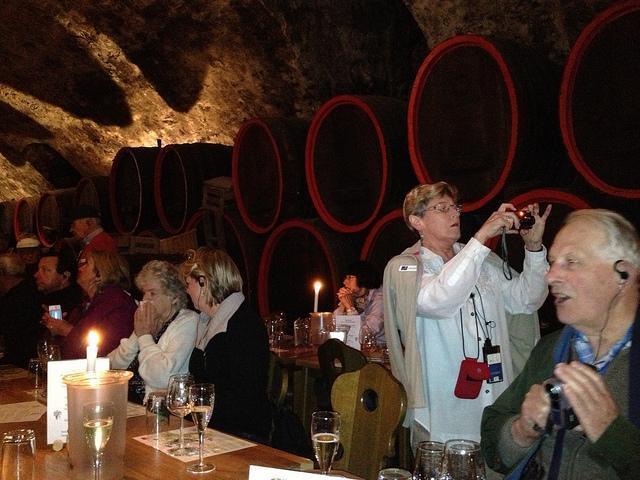How many people are visible?
Give a very brief answer. 7. 